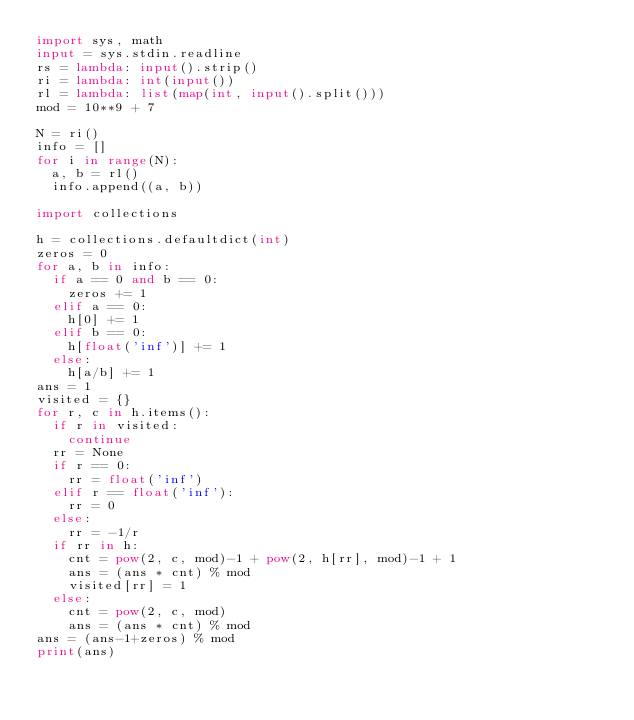Convert code to text. <code><loc_0><loc_0><loc_500><loc_500><_Python_>import sys, math
input = sys.stdin.readline
rs = lambda: input().strip()
ri = lambda: int(input())
rl = lambda: list(map(int, input().split()))
mod = 10**9 + 7

N = ri()
info = []
for i in range(N):
	a, b = rl()
	info.append((a, b))

import collections

h = collections.defaultdict(int)
zeros = 0
for a, b in info:
	if a == 0 and b == 0:
		zeros += 1
	elif a == 0:
		h[0] += 1
	elif b == 0:
		h[float('inf')] += 1
	else:
		h[a/b] += 1
ans = 1
visited = {}
for r, c in h.items():
	if r in visited:
		continue
	rr = None
	if r == 0:
		rr = float('inf')
	elif r == float('inf'):
		rr = 0
	else:
		rr = -1/r
	if rr in h:
		cnt = pow(2, c, mod)-1 + pow(2, h[rr], mod)-1 + 1
		ans = (ans * cnt) % mod
		visited[rr] = 1
	else:
		cnt = pow(2, c, mod)
		ans = (ans * cnt) % mod
ans = (ans-1+zeros) % mod
print(ans)
</code> 